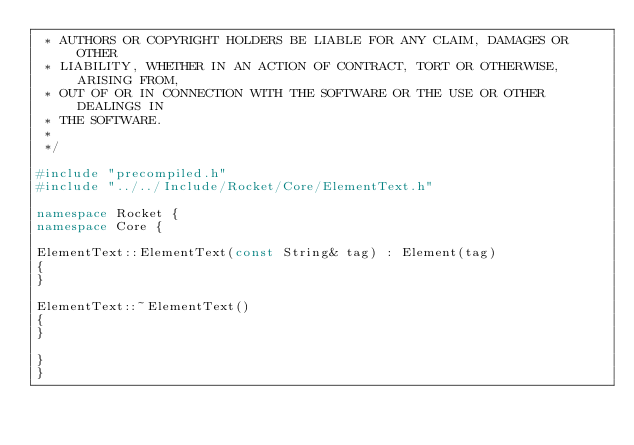Convert code to text. <code><loc_0><loc_0><loc_500><loc_500><_C++_> * AUTHORS OR COPYRIGHT HOLDERS BE LIABLE FOR ANY CLAIM, DAMAGES OR OTHER
 * LIABILITY, WHETHER IN AN ACTION OF CONTRACT, TORT OR OTHERWISE, ARISING FROM,
 * OUT OF OR IN CONNECTION WITH THE SOFTWARE OR THE USE OR OTHER DEALINGS IN
 * THE SOFTWARE.
 *
 */

#include "precompiled.h"
#include "../../Include/Rocket/Core/ElementText.h"

namespace Rocket {
namespace Core {

ElementText::ElementText(const String& tag) : Element(tag)
{
}

ElementText::~ElementText()
{
}

}
}
</code> 